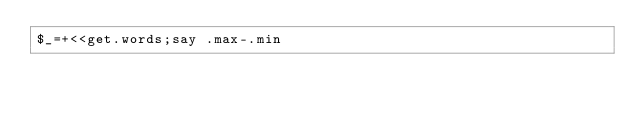Convert code to text. <code><loc_0><loc_0><loc_500><loc_500><_Perl_>$_=+<<get.words;say .max-.min</code> 